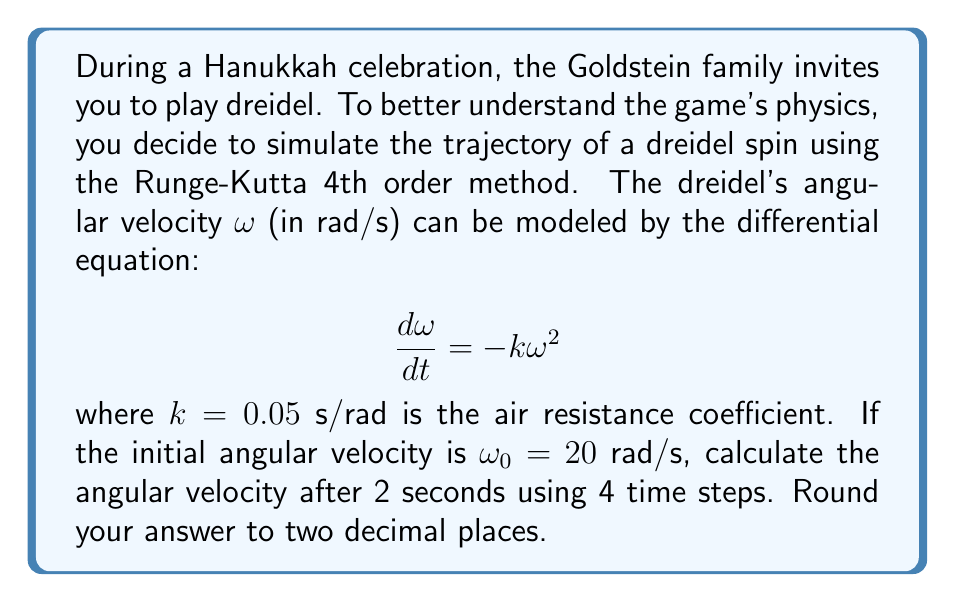Provide a solution to this math problem. To solve this problem, we'll use the Runge-Kutta 4th order method (RK4) to numerically integrate the given differential equation.

1) First, let's define our function $f(t, \omega) = -k\omega^2 = -0.05\omega^2$

2) We'll use 4 time steps, so $\Delta t = \frac{2\text{ s}}{4} = 0.5\text{ s}$

3) The RK4 method for each step is:

   $$\begin{align*}
   k_1 &= f(t_n, \omega_n) \\
   k_2 &= f(t_n + \frac{\Delta t}{2}, \omega_n + \frac{\Delta t}{2}k_1) \\
   k_3 &= f(t_n + \frac{\Delta t}{2}, \omega_n + \frac{\Delta t}{2}k_2) \\
   k_4 &= f(t_n + \Delta t, \omega_n + \Delta t k_3) \\
   \omega_{n+1} &= \omega_n + \frac{\Delta t}{6}(k_1 + 2k_2 + 2k_3 + k_4)
   \end{align*}$$

4) Let's calculate each step:

   Step 1: $t_0 = 0\text{ s}, \omega_0 = 20\text{ rad/s}$
   $$\begin{align*}
   k_1 &= f(0, 20) = -0.05(20)^2 = -20 \\
   k_2 &= f(0.25, 20 + 0.25(-20)) = f(0.25, 15) = -0.05(15)^2 = -11.25 \\
   k_3 &= f(0.25, 20 + 0.25(-11.25)) = f(0.25, 17.1875) = -0.05(17.1875)^2 = -14.7656 \\
   k_4 &= f(0.5, 20 + 0.5(-14.7656)) = f(0.5, 12.6172) = -0.05(12.6172)^2 = -7.9592 \\
   \omega_1 &= 20 + \frac{0.5}{6}(-20 - 22.5 - 29.5312 - 7.9592) = 13.3349\text{ rad/s}
   \end{align*}$$

   Step 2: $t_1 = 0.5\text{ s}, \omega_1 = 13.3349\text{ rad/s}$
   $$\begin{align*}
   k_1 &= -0.05(13.3349)^2 = -8.8905 \\
   k_2 &= -0.05(11.2169)^2 = -6.2909 \\
   k_3 &= -0.05(12.0227)^2 = -7.2272 \\
   k_4 &= -0.05(9.5213)^2 = -4.5328 \\
   \omega_2 &= 13.3349 - 2.2451 = 11.0898\text{ rad/s}
   \end{align*}$$

   Step 3: $t_2 = 1\text{ s}, \omega_2 = 11.0898\text{ rad/s}$
   $$\begin{align*}
   k_1 &= -0.05(11.0898)^2 = -6.1494 \\
   k_2 &= -0.05(9.7774)^2 = -4.7800 \\
   k_3 &= -0.05(10.2998)^2 = -5.3043 \\
   k_4 &= -0.05(8.7377)^2 = -3.8173 \\
   \omega_3 &= 11.0898 - 1.6709 = 9.4189\text{ rad/s}
   \end{align*}$$

   Step 4: $t_3 = 1.5\text{ s}, \omega_3 = 9.4189\text{ rad/s}$
   $$\begin{align*}
   k_1 &= -0.05(9.4189)^2 = -4.4358 \\
   k_2 &= -0.05(8.5011)^2 = -3.6134 \\
   k_3 &= -0.05(8.8837)^2 = -3.9461 \\
   k_4 &= -0.05(7.7459)^2 = -3.0001 \\
   \omega_4 &= 9.4189 - 1.2496 = 8.1693\text{ rad/s}
   \end{align*}$$

5) After 2 seconds (4 steps), the angular velocity is approximately 8.17 rad/s.
Answer: $8.17\text{ rad/s}$ 